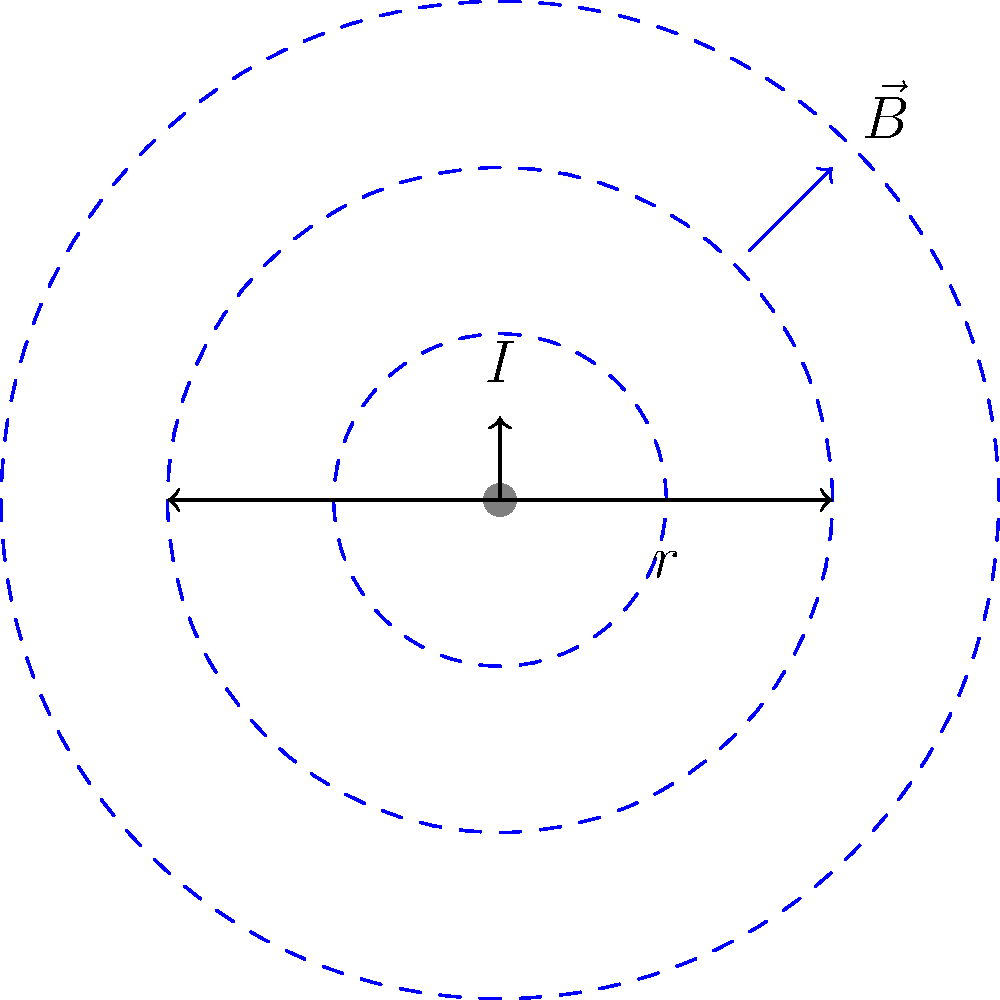In a satirical twist on electromagnetic fields, imagine Bill Maher hosting a game show called "Magnetic Mayhem." Contestants must calculate the magnetic field strength around a straight current-carrying wire. Given that the current $I$ is 5 A and you're standing 0.2 m away from the wire, what's the magnitude of the magnetic field strength at your location? (Assume $\mu_0 = 4\pi \times 10^{-7}$ T⋅m/A) Let's break this down in a way that would make even Bill Maher appreciate the logic:

1) The magnetic field strength $B$ around a straight current-carrying wire is given by the equation:

   $$B = \frac{\mu_0 I}{2\pi r}$$

   Where:
   - $\mu_0$ is the permeability of free space
   - $I$ is the current in the wire
   - $r$ is the distance from the wire

2) We're given:
   - $\mu_0 = 4\pi \times 10^{-7}$ T⋅m/A
   - $I = 5$ A
   - $r = 0.2$ m

3) Let's plug these values into our equation:

   $$B = \frac{(4\pi \times 10^{-7})(5)}{2\pi(0.2)}$$

4) Simplify:
   $$B = \frac{20\pi \times 10^{-7}}{2\pi(0.2)} = \frac{10 \times 10^{-7}}{0.2} = 5 \times 10^{-6}$$

5) Therefore, the magnetic field strength is $5 \times 10^{-6}$ T or 5 µT.

And there you have it! Even in the realm of electromagnetic fields, the truth comes full circle – much like Bill Maher's satirical commentary on current events.
Answer: 5 µT 